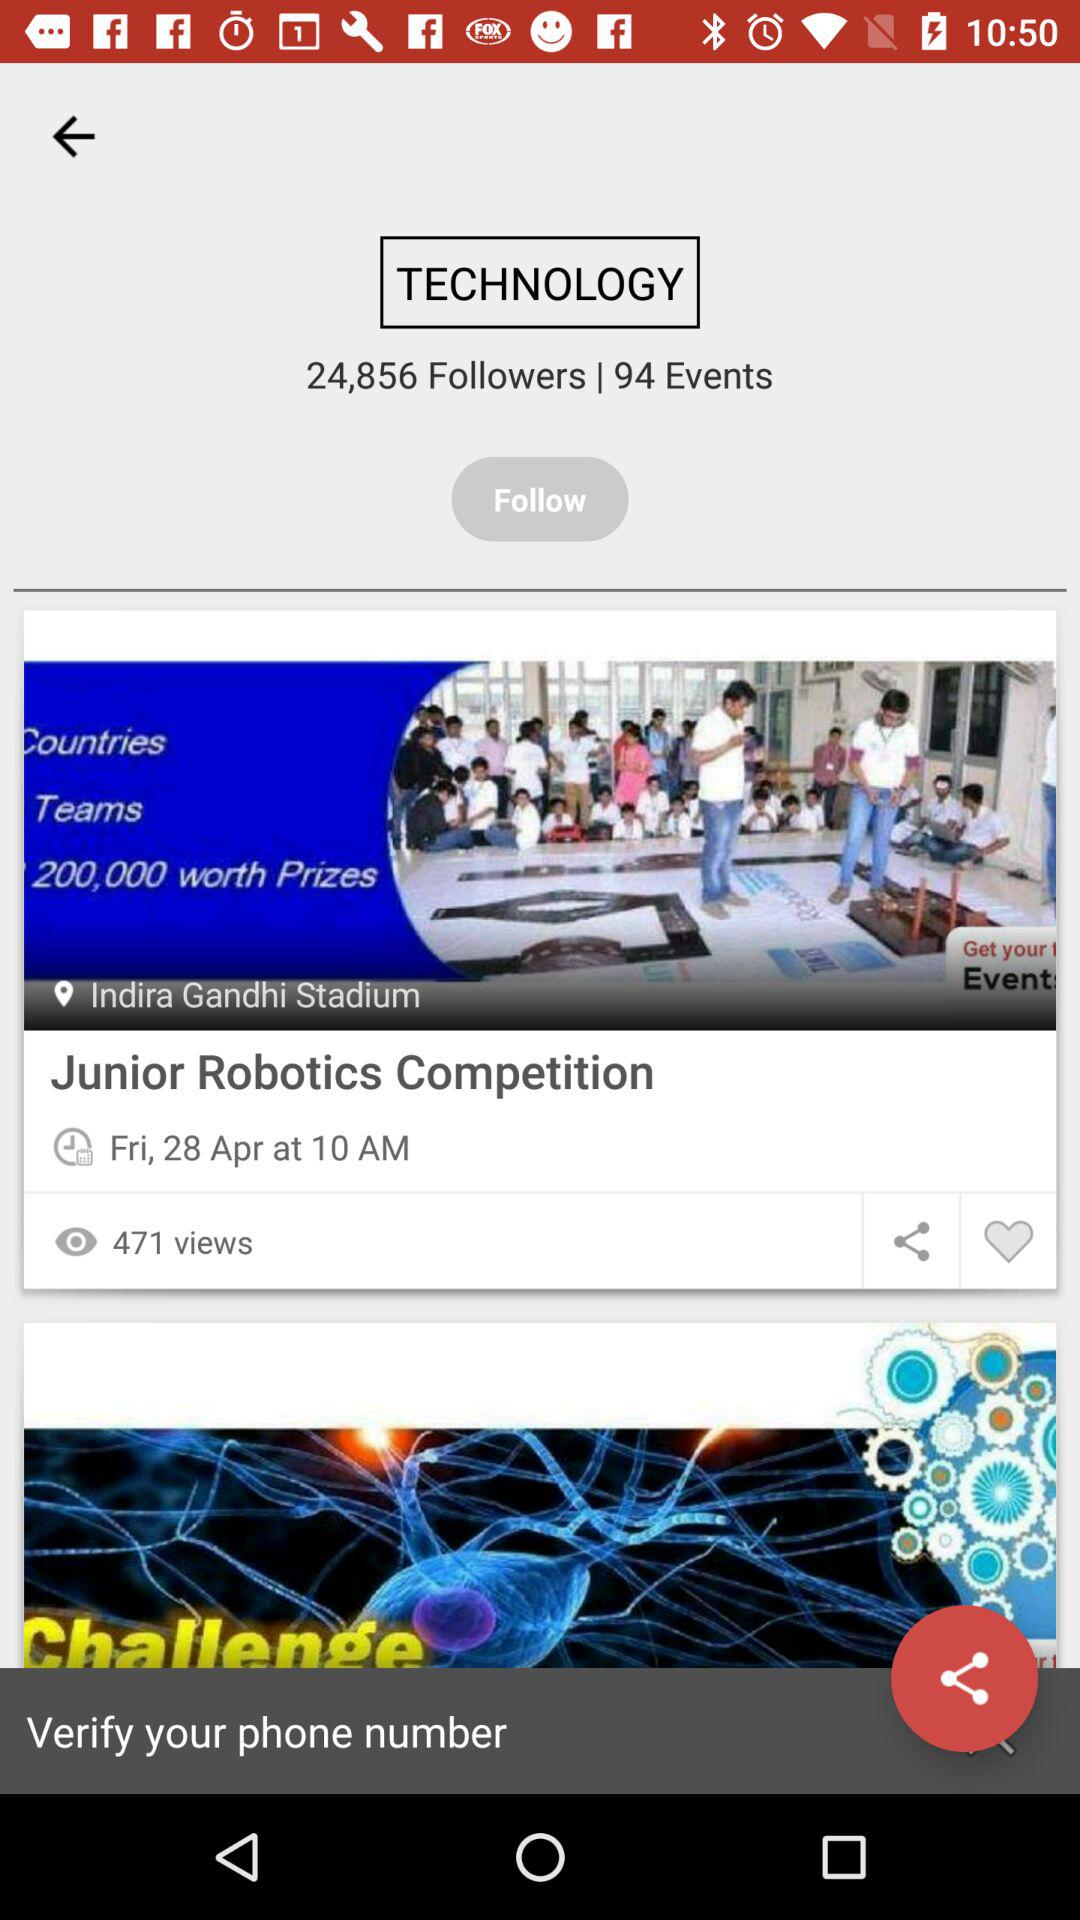How many followers does the account have?
Answer the question using a single word or phrase. 24,856 